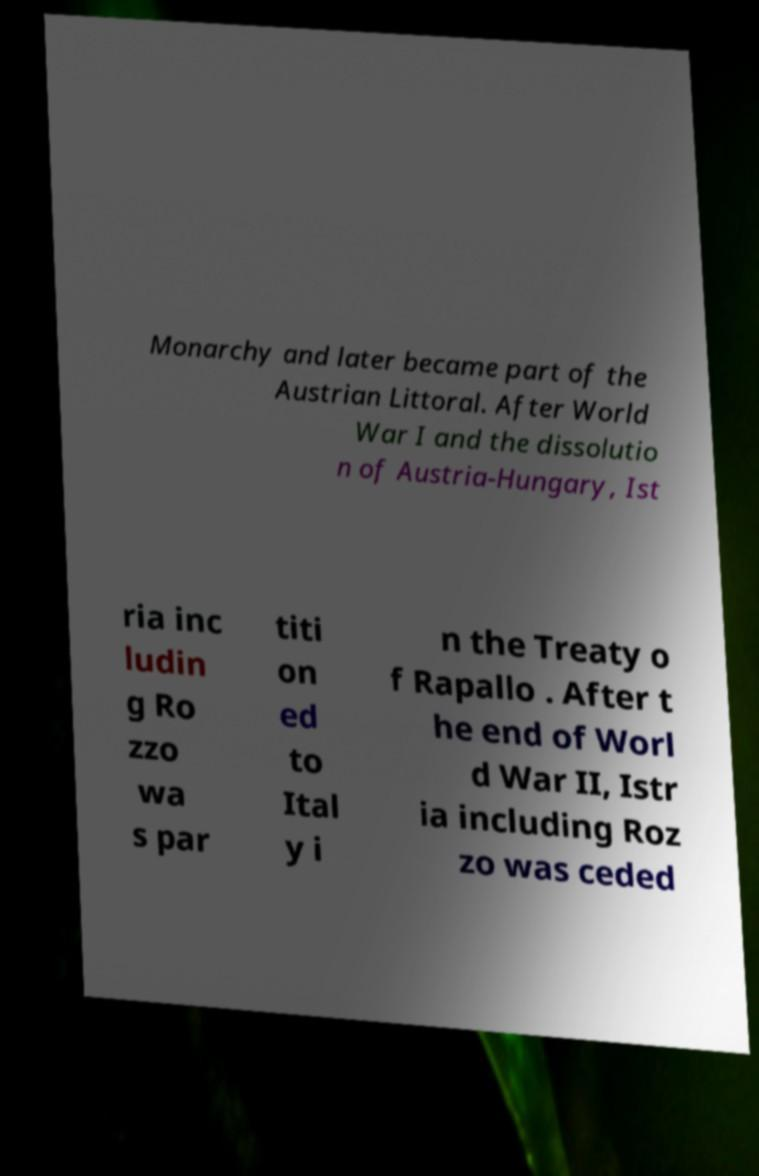For documentation purposes, I need the text within this image transcribed. Could you provide that? Monarchy and later became part of the Austrian Littoral. After World War I and the dissolutio n of Austria-Hungary, Ist ria inc ludin g Ro zzo wa s par titi on ed to Ital y i n the Treaty o f Rapallo . After t he end of Worl d War II, Istr ia including Roz zo was ceded 